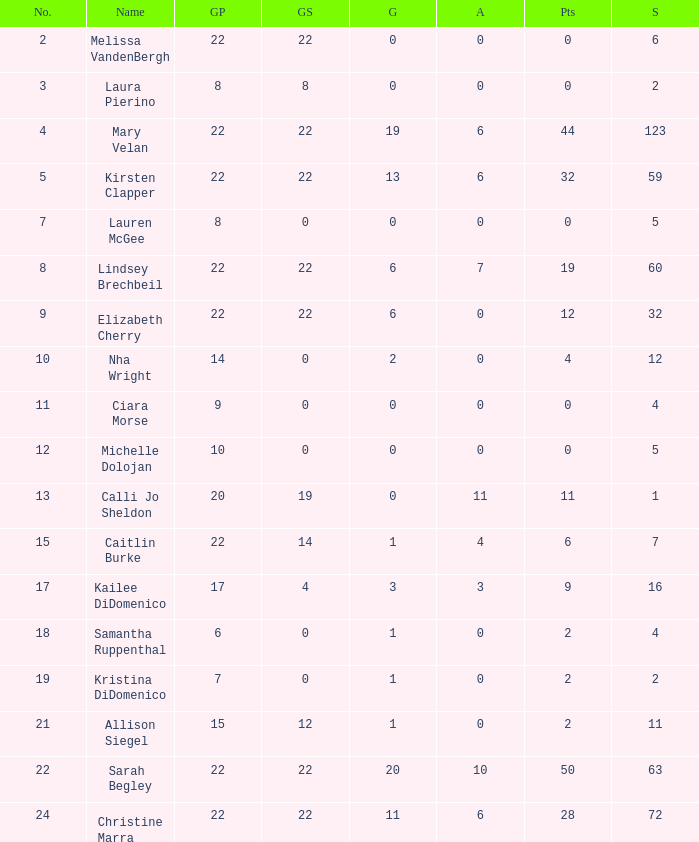How many numbers belong to the player with 10 assists?  1.0. 